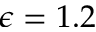<formula> <loc_0><loc_0><loc_500><loc_500>\epsilon = 1 . 2</formula> 